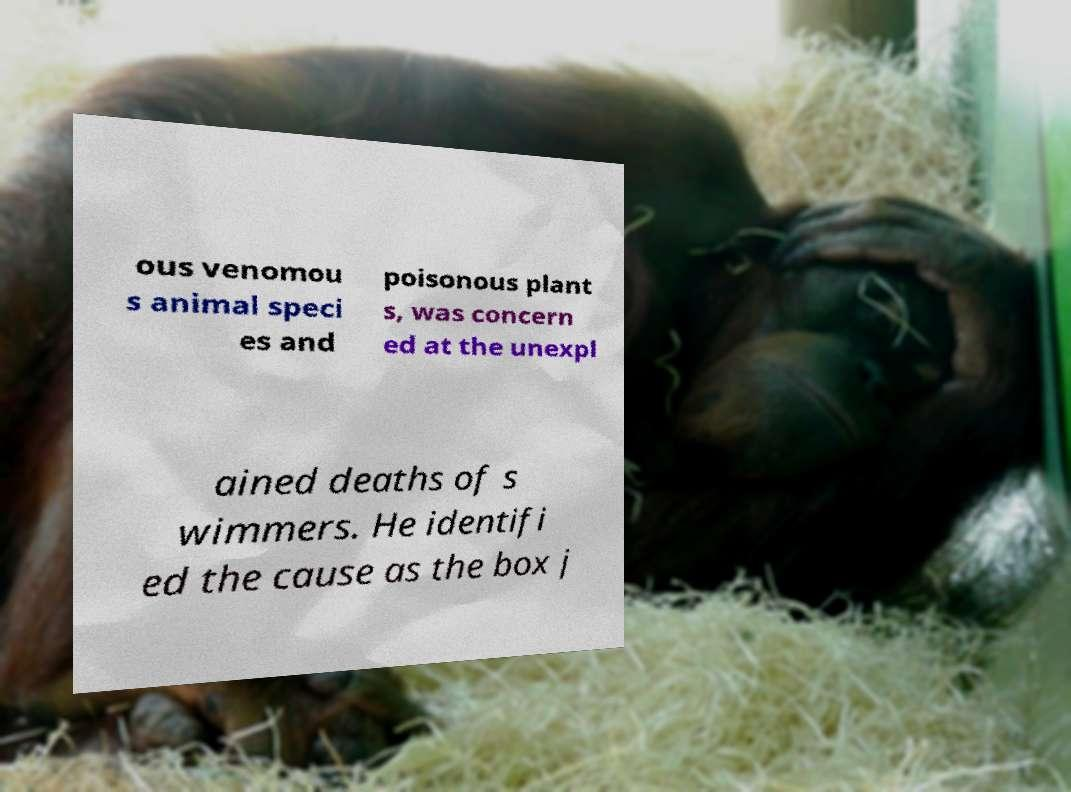What messages or text are displayed in this image? I need them in a readable, typed format. ous venomou s animal speci es and poisonous plant s, was concern ed at the unexpl ained deaths of s wimmers. He identifi ed the cause as the box j 